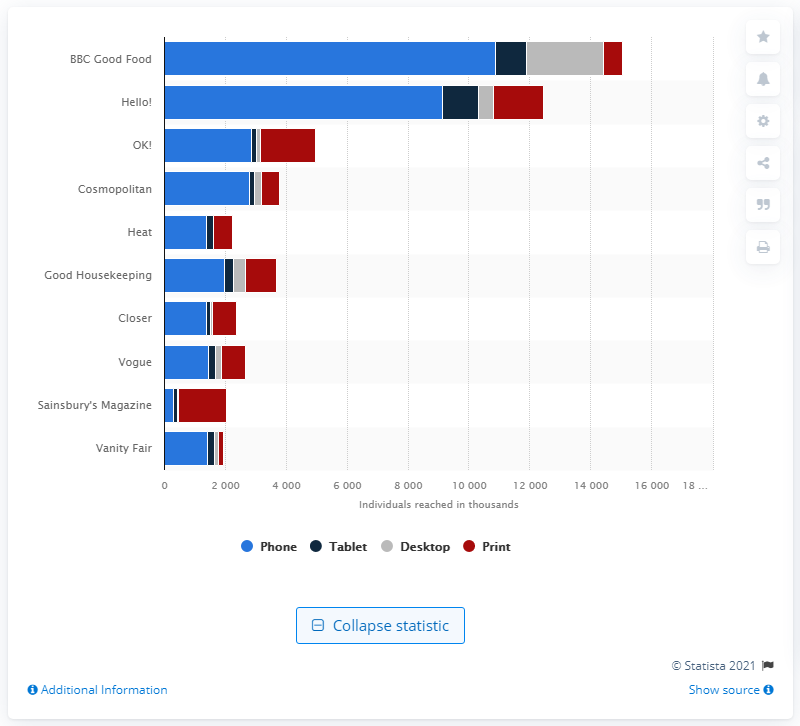Specify some key components in this picture. BBC Good Food was the most popular women's magazine in the United Kingdom from April 2019 to March 2020. According to the magazine "OK!", it had the highest reach via print. 